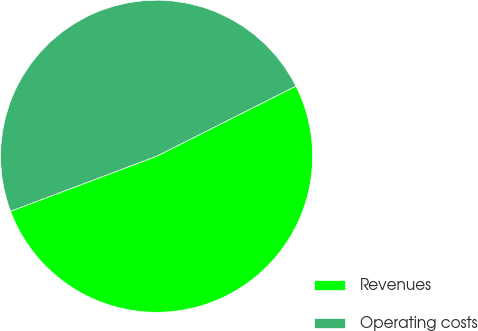<chart> <loc_0><loc_0><loc_500><loc_500><pie_chart><fcel>Revenues<fcel>Operating costs<nl><fcel>51.69%<fcel>48.31%<nl></chart> 